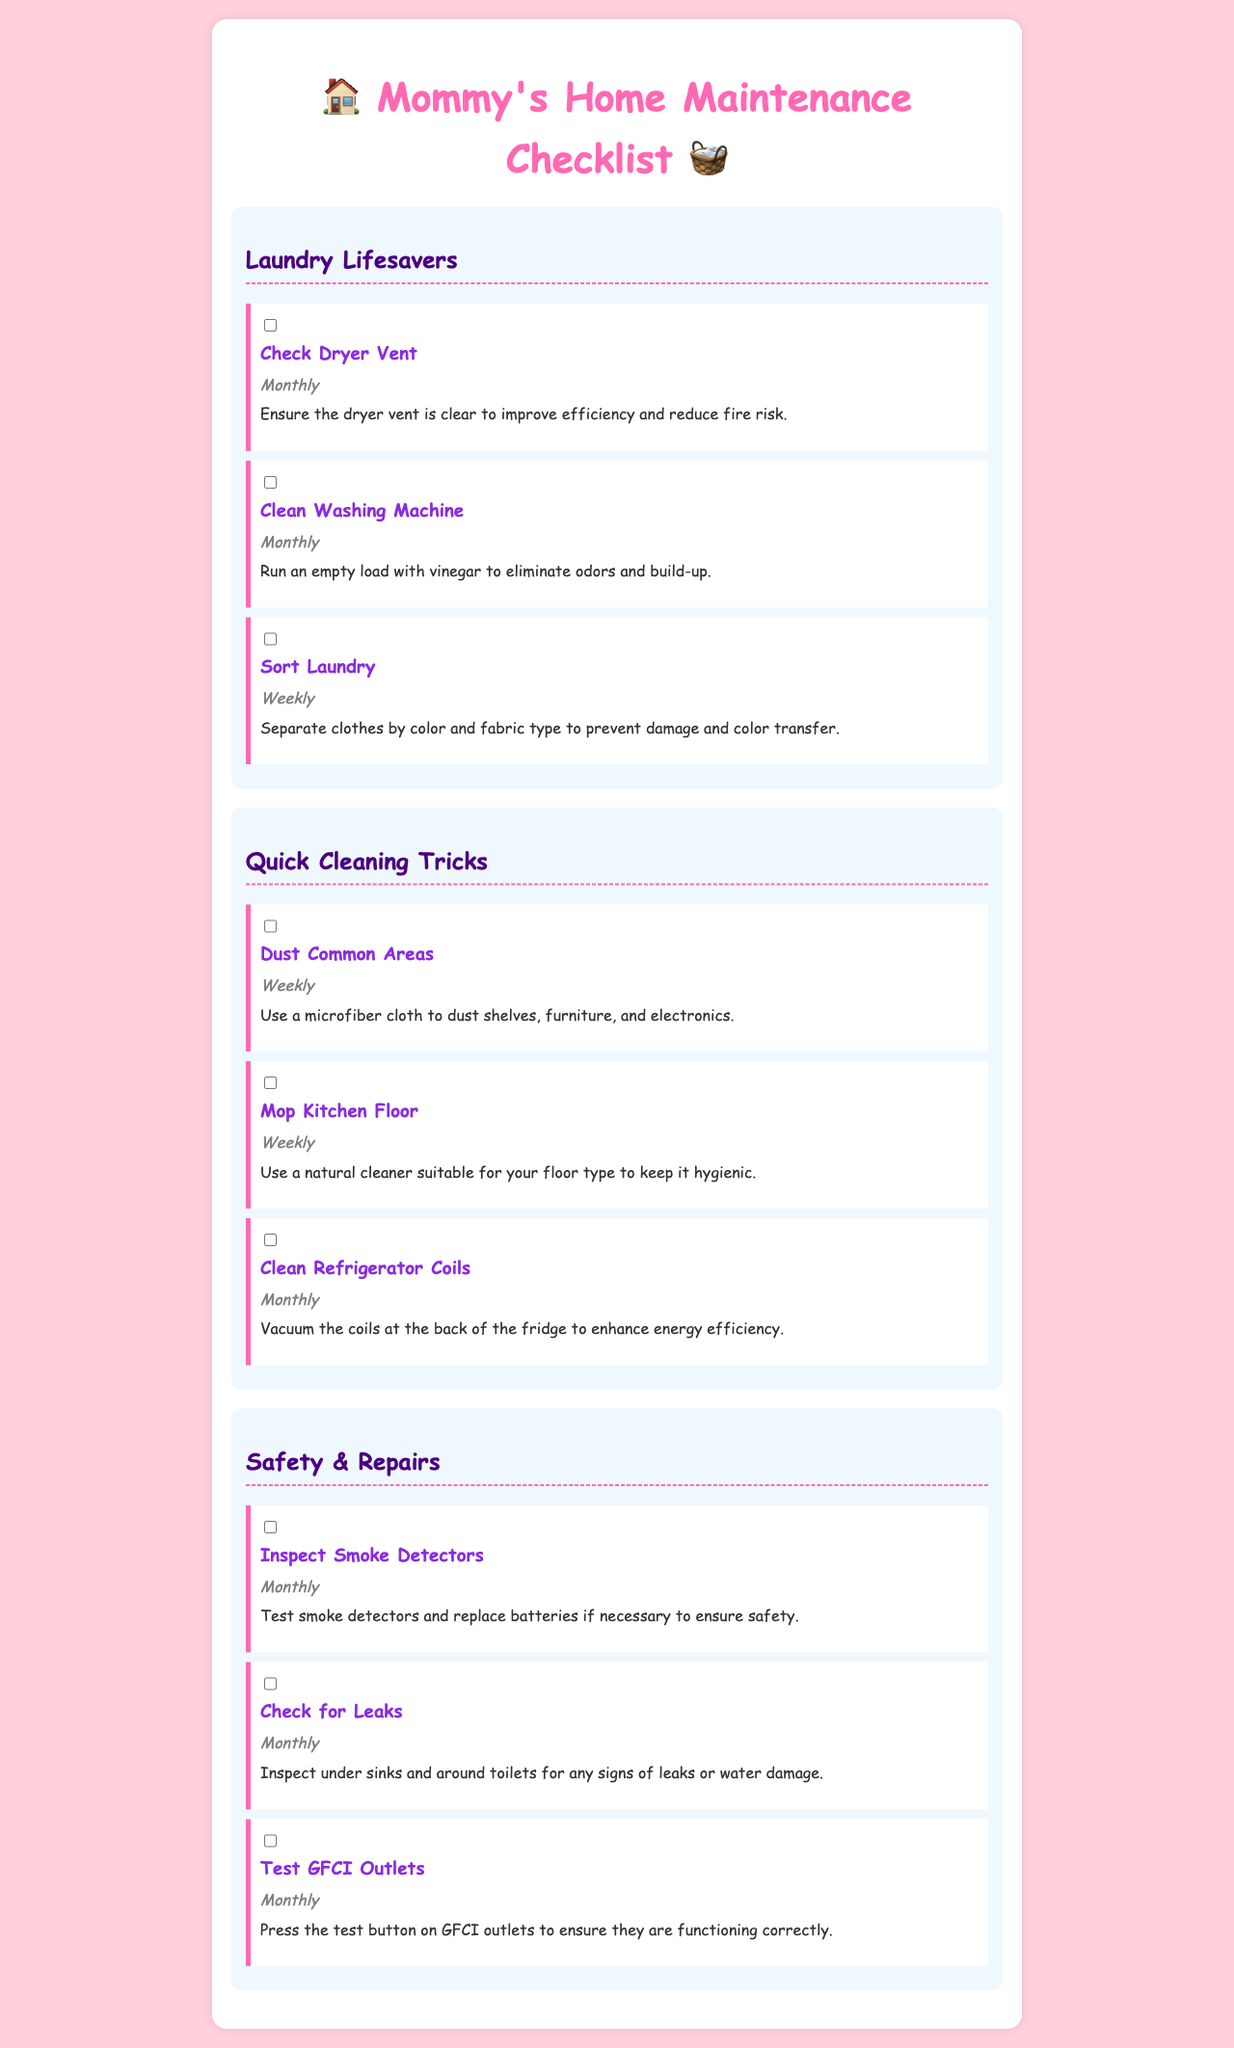what is the title of the document? The title is prominently displayed at the top of the document, which is "Home Maintenance Checklist for Busy Moms."
Answer: Home Maintenance Checklist for Busy Moms how often should you check the dryer vent? The document specifies that the dryer vent should be checked monthly.
Answer: Monthly what is one task listed under Quick Cleaning Tricks? The section describes several tasks, one of which is "Dust Common Areas."
Answer: Dust Common Areas how many tasks are listed under Safety & Repairs? The section contains a total of three tasks regarding safety and repairs.
Answer: Three what is the frequency for cleaning the washing machine? The checklist indicates that the washing machine should be cleaned on a monthly basis.
Answer: Monthly why should you sort laundry? The purpose of sorting laundry is to separate clothes by color and fabric type, which prevents damage and color transfer.
Answer: Prevent damage and color transfer what type of cleaner should be used to mop the kitchen floor? The document advises using a natural cleaner suitable for the floor type when mopping the kitchen floor.
Answer: Natural cleaner how many sections are there in the document? The document includes three main sections regarding different maintenance areas: laundry, cleaning, and safety/repairs.
Answer: Three 